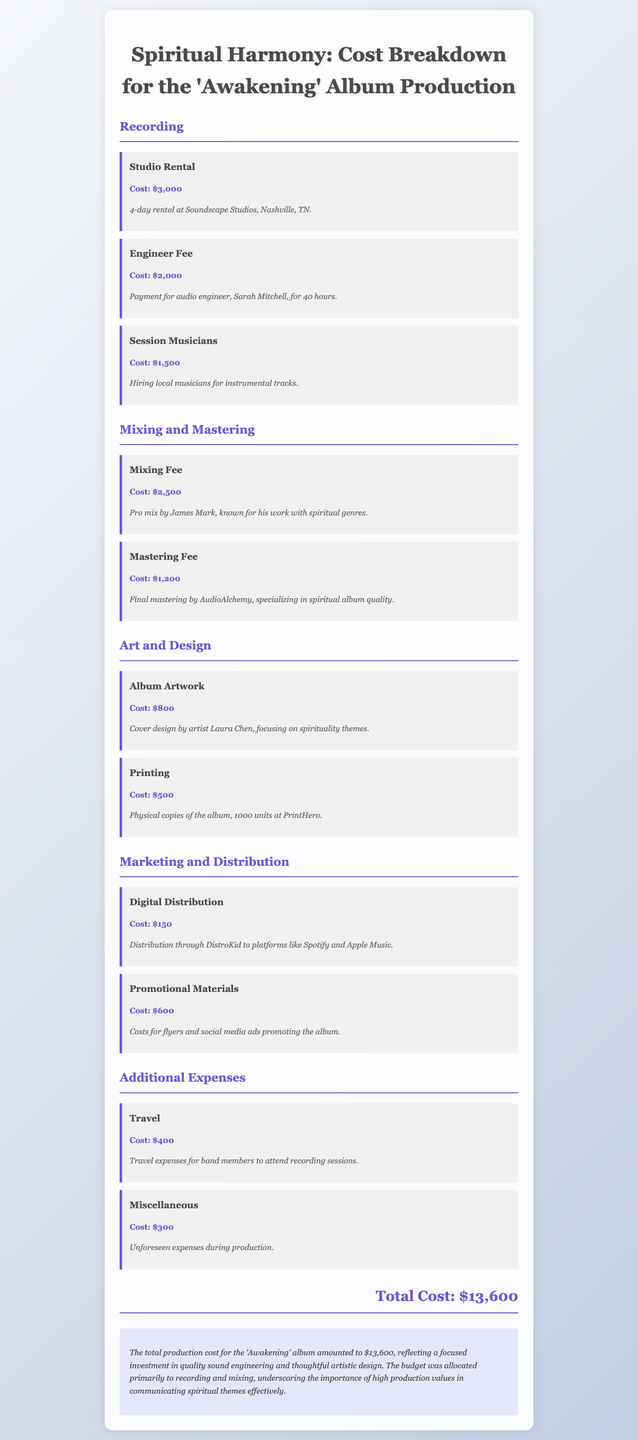What is the total cost of the album production? The total cost is listed at the end of the document, summarizing the overall expenditure on the album.
Answer: $13,600 Who was the audio engineer for the album? The document specifies the name of the audio engineer hired for the production.
Answer: Sarah Mitchell How much was allocated for studio rental? The cost for renting the studio is detailed in the recording section of the document.
Answer: $3,000 What is the cost of album artwork? The document provides the specific expense for the album's cover design.
Answer: $800 Who designed the album cover? The artist responsible for the album artwork is mentioned in the cost breakdown.
Answer: Laura Chen What was the expense for digital distribution? The cost for distributing the album digitally through a specific service is noted in the marketing section.
Answer: $150 How much did the mixing fee amount to? The amount charged for the mixing service is listed under mixing and mastering expenses.
Answer: $2,500 What percentage of the total cost is attributed to recording? To answer this, the costs of studio rental, engineer fee, and session musicians need to be summed and compared to the total.
Answer: $6,500 What was spent on promotional materials? The total cost for promotional materials is explicitly mentioned in the marketing and distribution section.
Answer: $600 